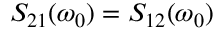<formula> <loc_0><loc_0><loc_500><loc_500>S _ { 2 1 } ( \omega _ { 0 } ) = S _ { 1 2 } ( \omega _ { 0 } )</formula> 